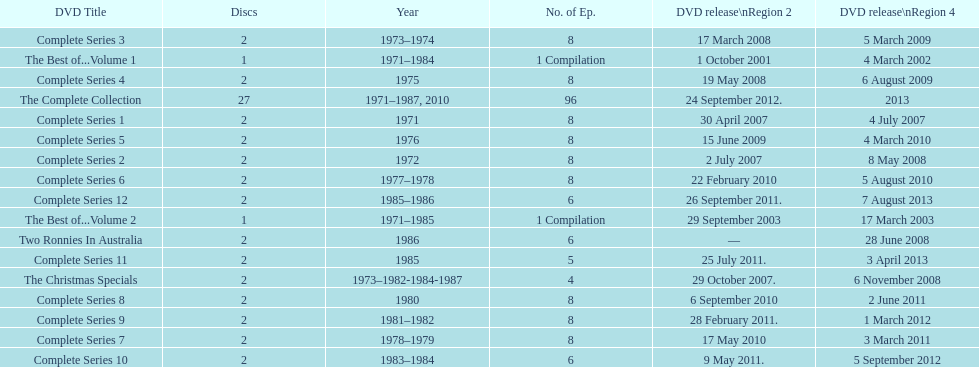Could you parse the entire table? {'header': ['DVD Title', 'Discs', 'Year', 'No. of Ep.', 'DVD release\\nRegion 2', 'DVD release\\nRegion 4'], 'rows': [['Complete Series 3', '2', '1973–1974', '8', '17 March 2008', '5 March 2009'], ['The Best of...Volume 1', '1', '1971–1984', '1 Compilation', '1 October 2001', '4 March 2002'], ['Complete Series 4', '2', '1975', '8', '19 May 2008', '6 August 2009'], ['The Complete Collection', '27', '1971–1987, 2010', '96', '24 September 2012.', '2013'], ['Complete Series 1', '2', '1971', '8', '30 April 2007', '4 July 2007'], ['Complete Series 5', '2', '1976', '8', '15 June 2009', '4 March 2010'], ['Complete Series 2', '2', '1972', '8', '2 July 2007', '8 May 2008'], ['Complete Series 6', '2', '1977–1978', '8', '22 February 2010', '5 August 2010'], ['Complete Series 12', '2', '1985–1986', '6', '26 September 2011.', '7 August 2013'], ['The Best of...Volume 2', '1', '1971–1985', '1 Compilation', '29 September 2003', '17 March 2003'], ['Two Ronnies In Australia', '2', '1986', '6', '—', '28 June 2008'], ['Complete Series 11', '2', '1985', '5', '25 July 2011.', '3 April 2013'], ['The Christmas Specials', '2', '1973–1982-1984-1987', '4', '29 October 2007.', '6 November 2008'], ['Complete Series 8', '2', '1980', '8', '6 September 2010', '2 June 2011'], ['Complete Series 9', '2', '1981–1982', '8', '28 February 2011.', '1 March 2012'], ['Complete Series 7', '2', '1978–1979', '8', '17 May 2010', '3 March 2011'], ['Complete Series 10', '2', '1983–1984', '6', '9 May 2011.', '5 September 2012']]} How many series had 8 episodes? 9. 